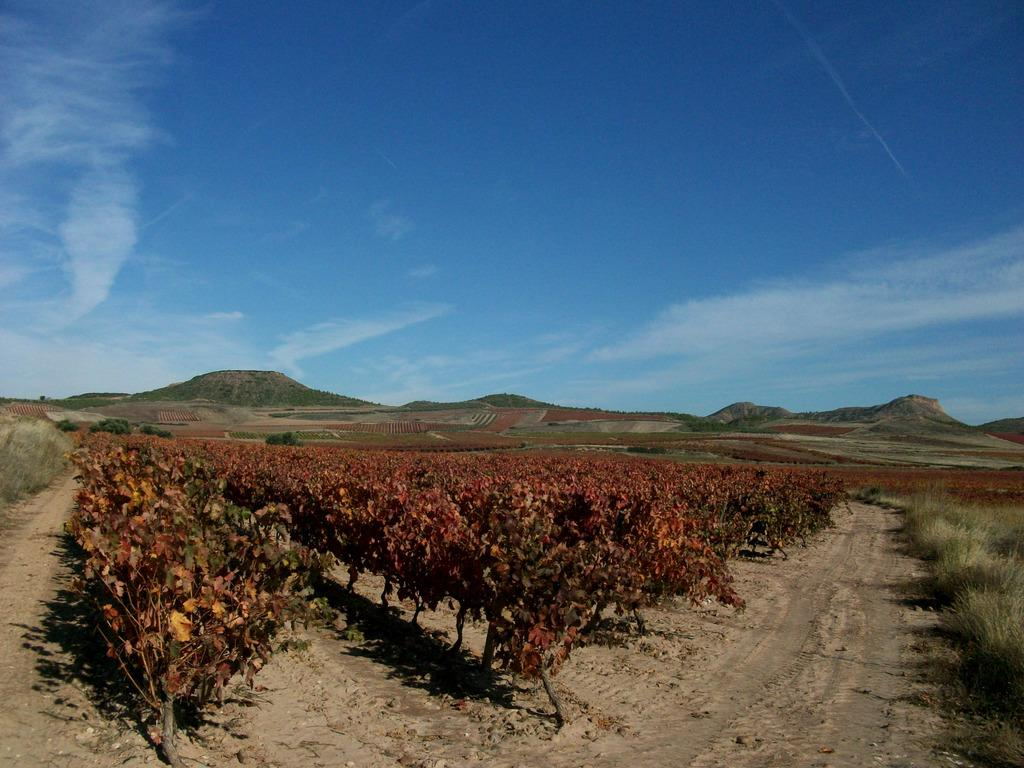What type of plants can be seen in the image? There are plants in maroon color in the image. What color is the grass in the image? There is grass in green color in the image. What can be seen in the background of the image? There are mountains visible in the background of the image. What colors are present in the sky in the image? The sky is blue and white in color. Can you see any farmers working with the plants in the image? There is no farmer present in the image. Are there any dinosaurs visible in the image? There are no dinosaurs present in the image. 